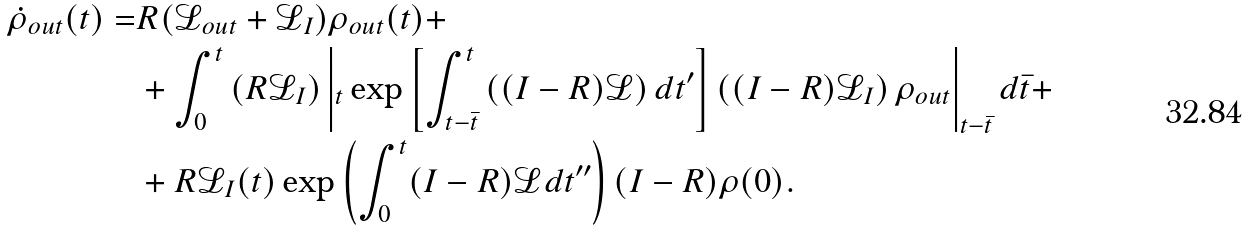<formula> <loc_0><loc_0><loc_500><loc_500>\dot { \rho } _ { o u t } ( t ) = & R ( \mathcal { L } _ { o u t } + \mathcal { L } _ { I } ) \rho _ { o u t } ( t ) + \\ & + \int _ { 0 } ^ { t } \left ( R \mathcal { L } _ { I } \right ) \left | _ { t } \exp \left [ \int _ { t - \bar { t } } ^ { t } \left ( ( I - R ) \mathcal { L } \right ) d t ^ { \prime } \right ] \left ( ( I - R ) \mathcal { L } _ { I } \right ) \rho _ { o u t } \right | _ { t - \bar { t } } d \bar { t } + \\ & + R \mathcal { L } _ { I } ( t ) \exp \left ( \int _ { 0 } ^ { t } ( I - R ) \mathcal { L } d t ^ { \prime \prime } \right ) ( I - R ) \rho ( 0 ) .</formula> 